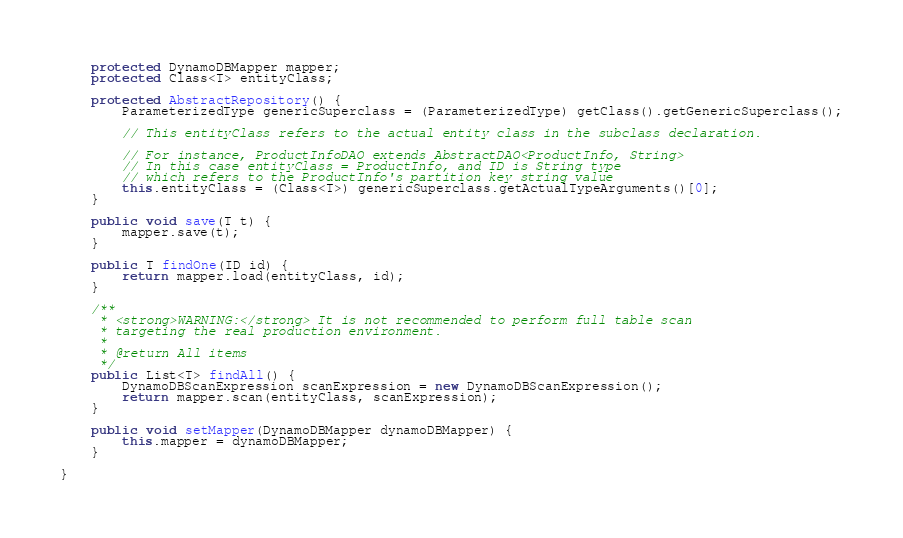<code> <loc_0><loc_0><loc_500><loc_500><_Java_>
    protected DynamoDBMapper mapper;
    protected Class<T> entityClass;

    protected AbstractRepository() {
        ParameterizedType genericSuperclass = (ParameterizedType) getClass().getGenericSuperclass();

        // This entityClass refers to the actual entity class in the subclass declaration.

        // For instance, ProductInfoDAO extends AbstractDAO<ProductInfo, String>
        // In this case entityClass = ProductInfo, and ID is String type
        // which refers to the ProductInfo's partition key string value
        this.entityClass = (Class<T>) genericSuperclass.getActualTypeArguments()[0];
    }

    public void save(T t) {
        mapper.save(t);
    }

    public T findOne(ID id) {
        return mapper.load(entityClass, id);
    }

    /**
     * <strong>WARNING:</strong> It is not recommended to perform full table scan
     * targeting the real production environment.
     *
     * @return All items
     */
    public List<T> findAll() {
        DynamoDBScanExpression scanExpression = new DynamoDBScanExpression();
        return mapper.scan(entityClass, scanExpression);
    }

    public void setMapper(DynamoDBMapper dynamoDBMapper) {
        this.mapper = dynamoDBMapper;
    }

}
</code> 